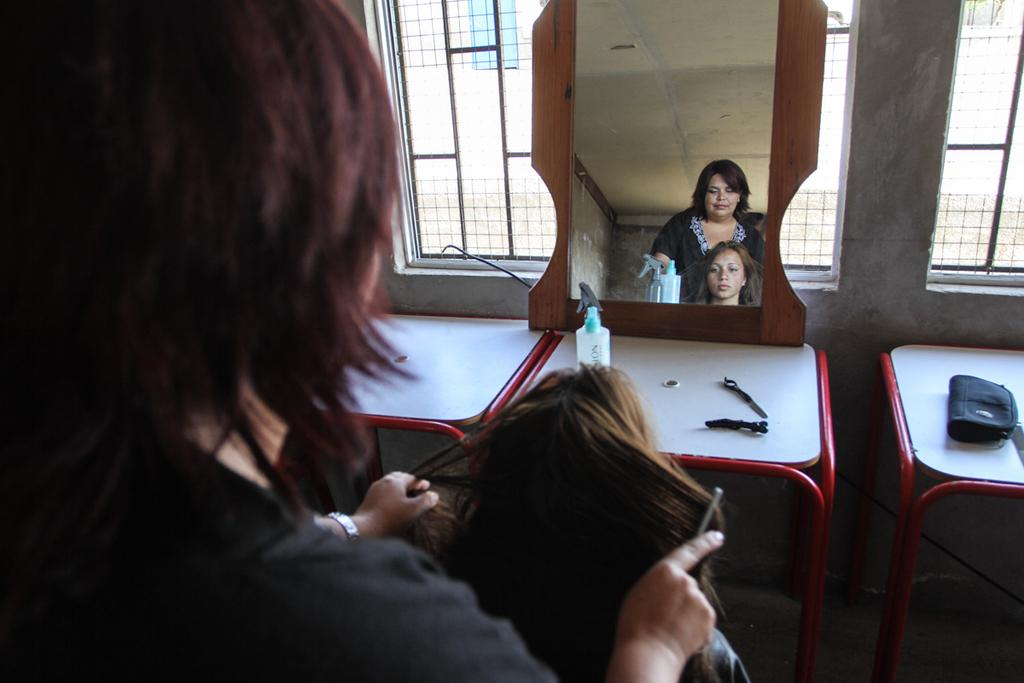How many women can be seen in the background of the image? There are two women in the background of the image. What is present in the image besides the women? There is a table, a mirror, and a window in the image. What is the grandfather doing in the image? There is no grandfather present in the image. How many dads are visible in the image? There is no dad present in the image. 